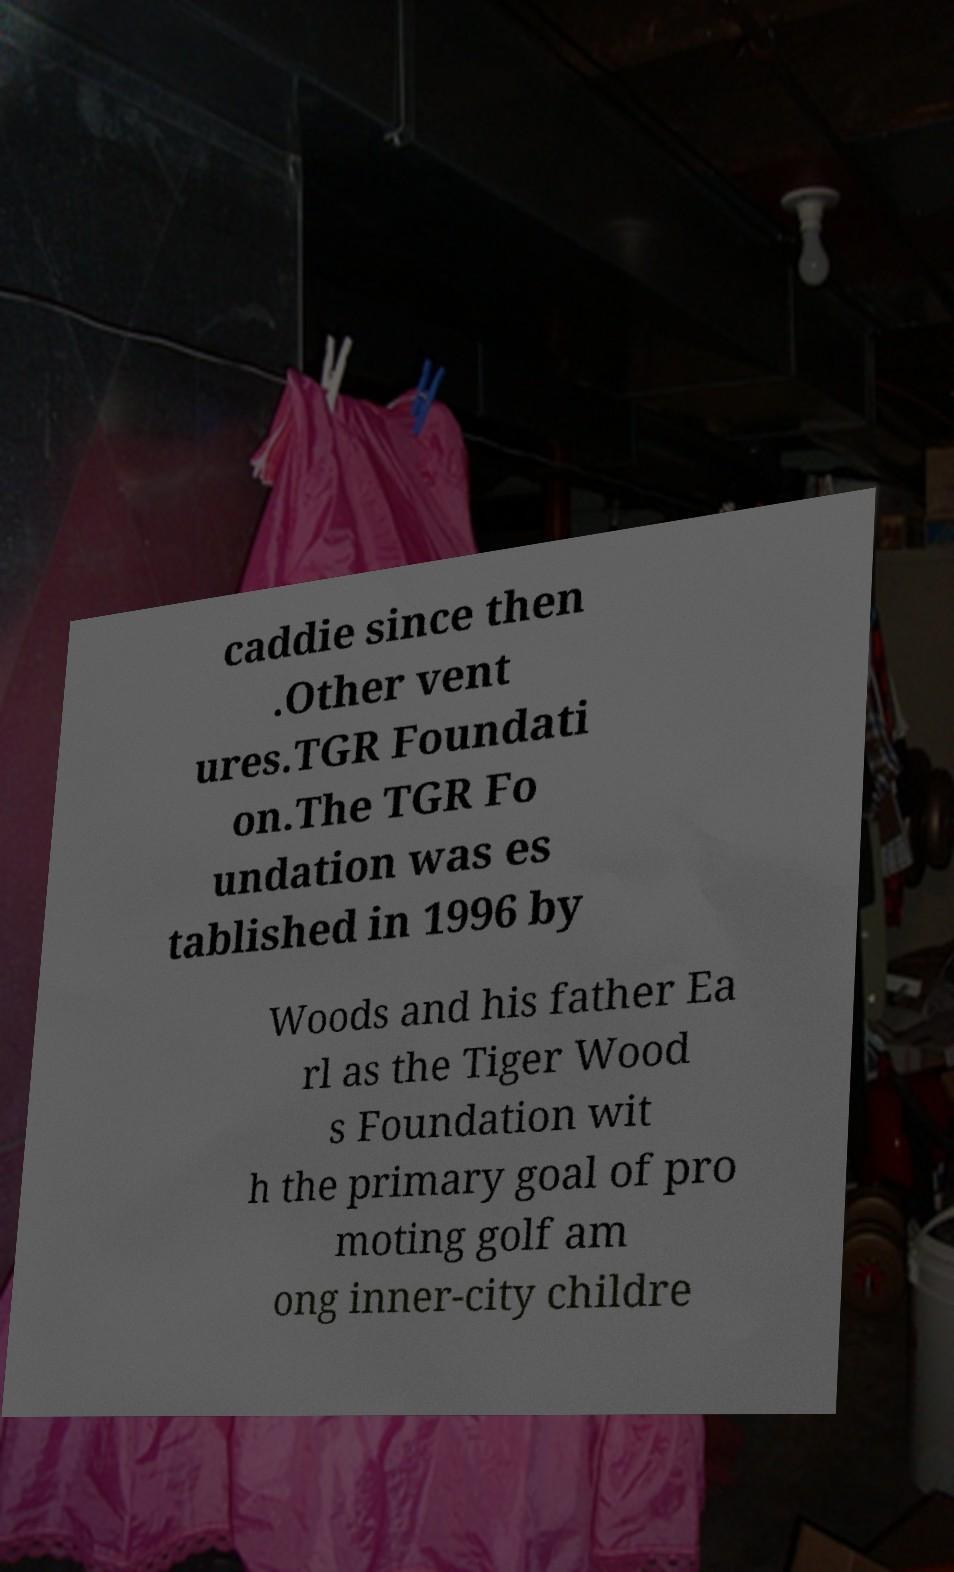Can you accurately transcribe the text from the provided image for me? caddie since then .Other vent ures.TGR Foundati on.The TGR Fo undation was es tablished in 1996 by Woods and his father Ea rl as the Tiger Wood s Foundation wit h the primary goal of pro moting golf am ong inner-city childre 